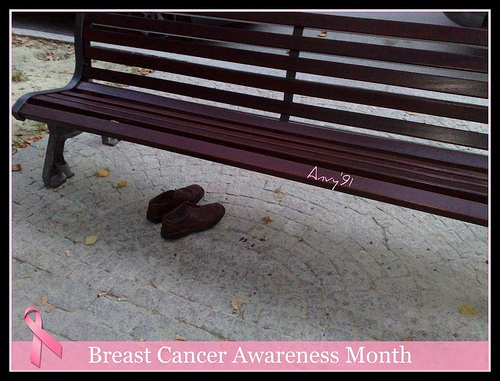Describe the objects in this image and their specific colors. I can see a bench in black, gray, and darkgray tones in this image. 